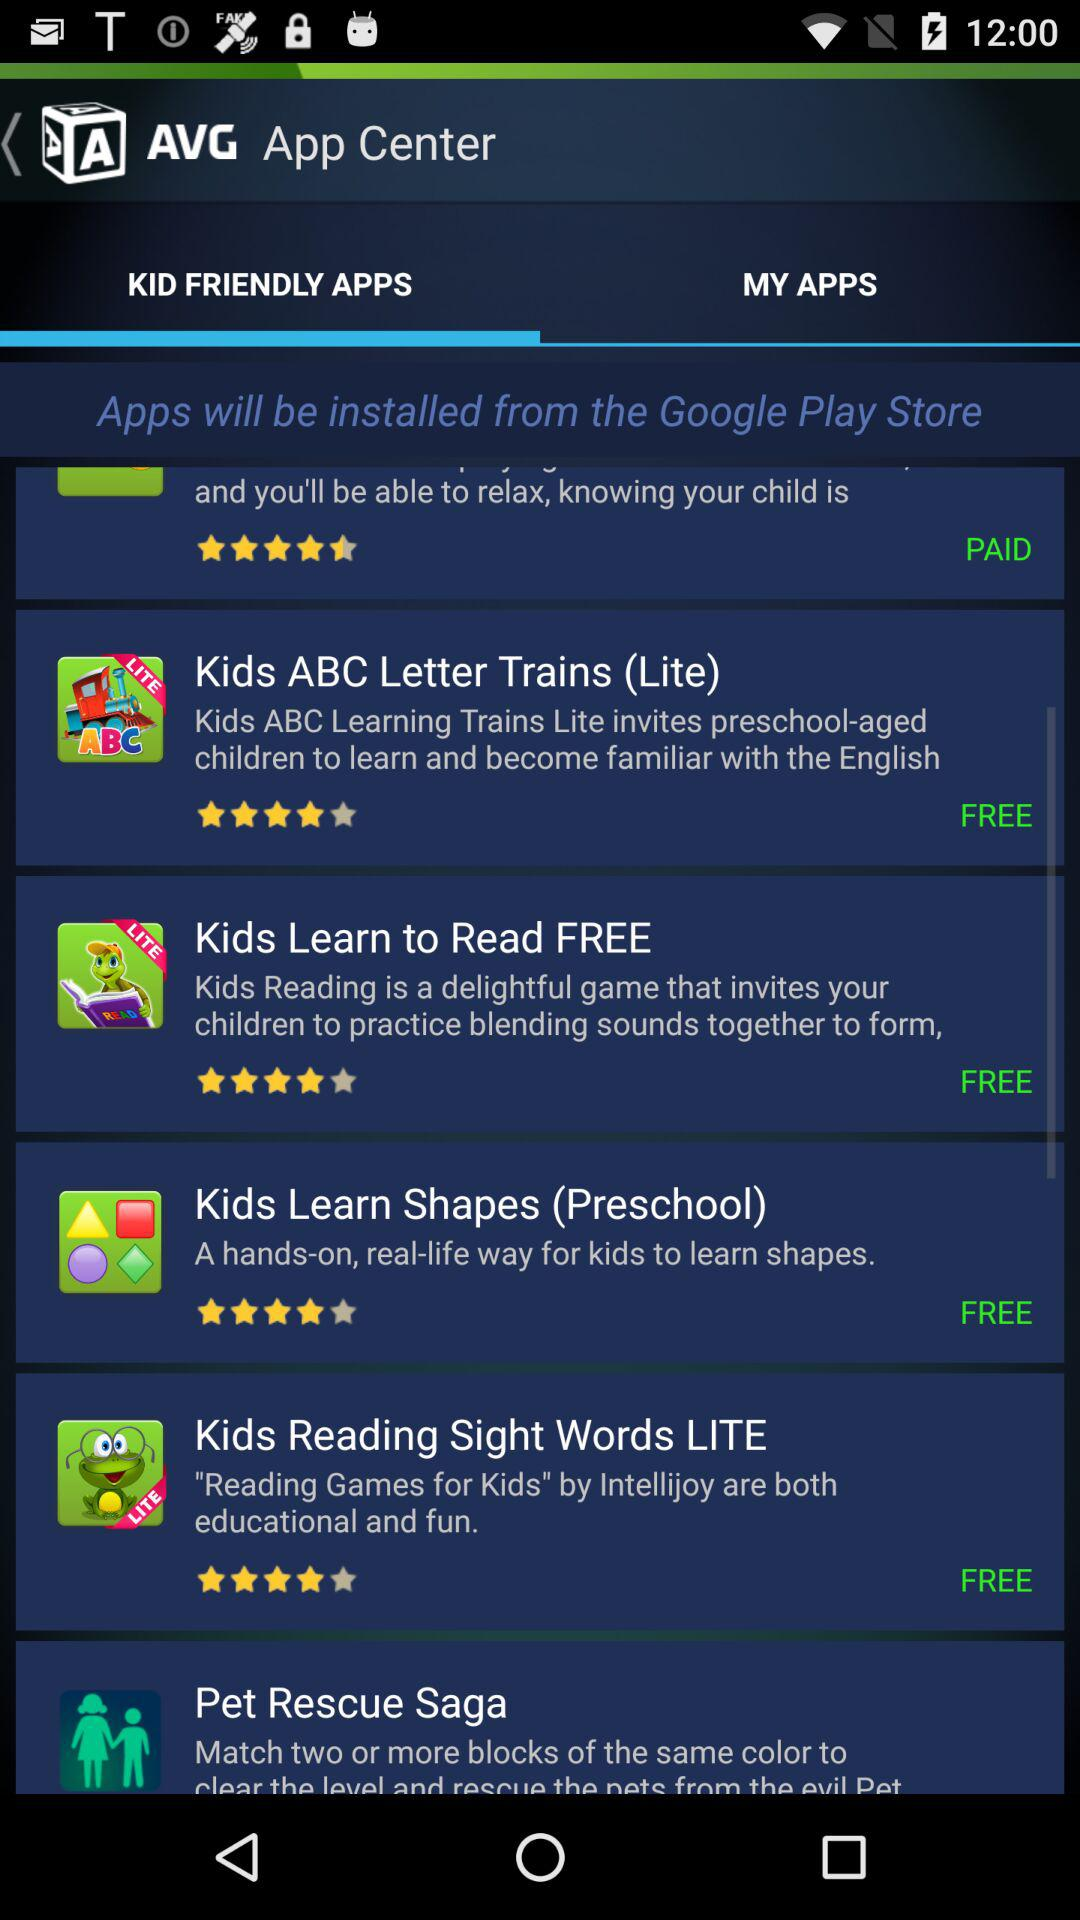What is the star rating of the application "Kids Reading Sight Words LITE"? The rating is 4 stars. 